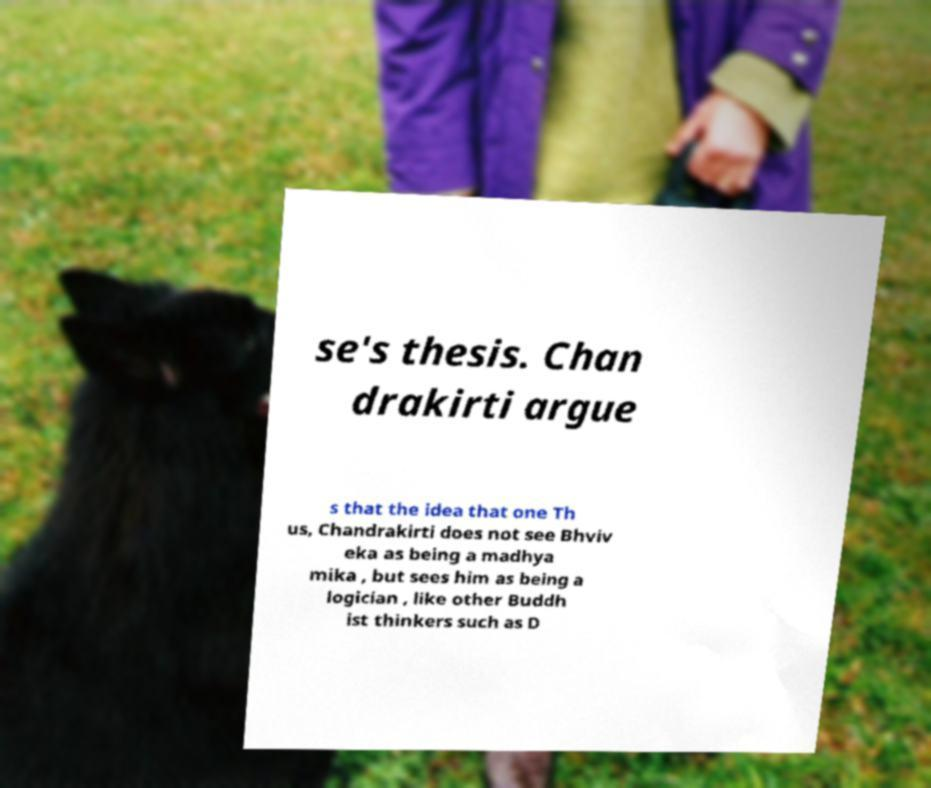Can you accurately transcribe the text from the provided image for me? se's thesis. Chan drakirti argue s that the idea that one Th us, Chandrakirti does not see Bhviv eka as being a madhya mika , but sees him as being a logician , like other Buddh ist thinkers such as D 